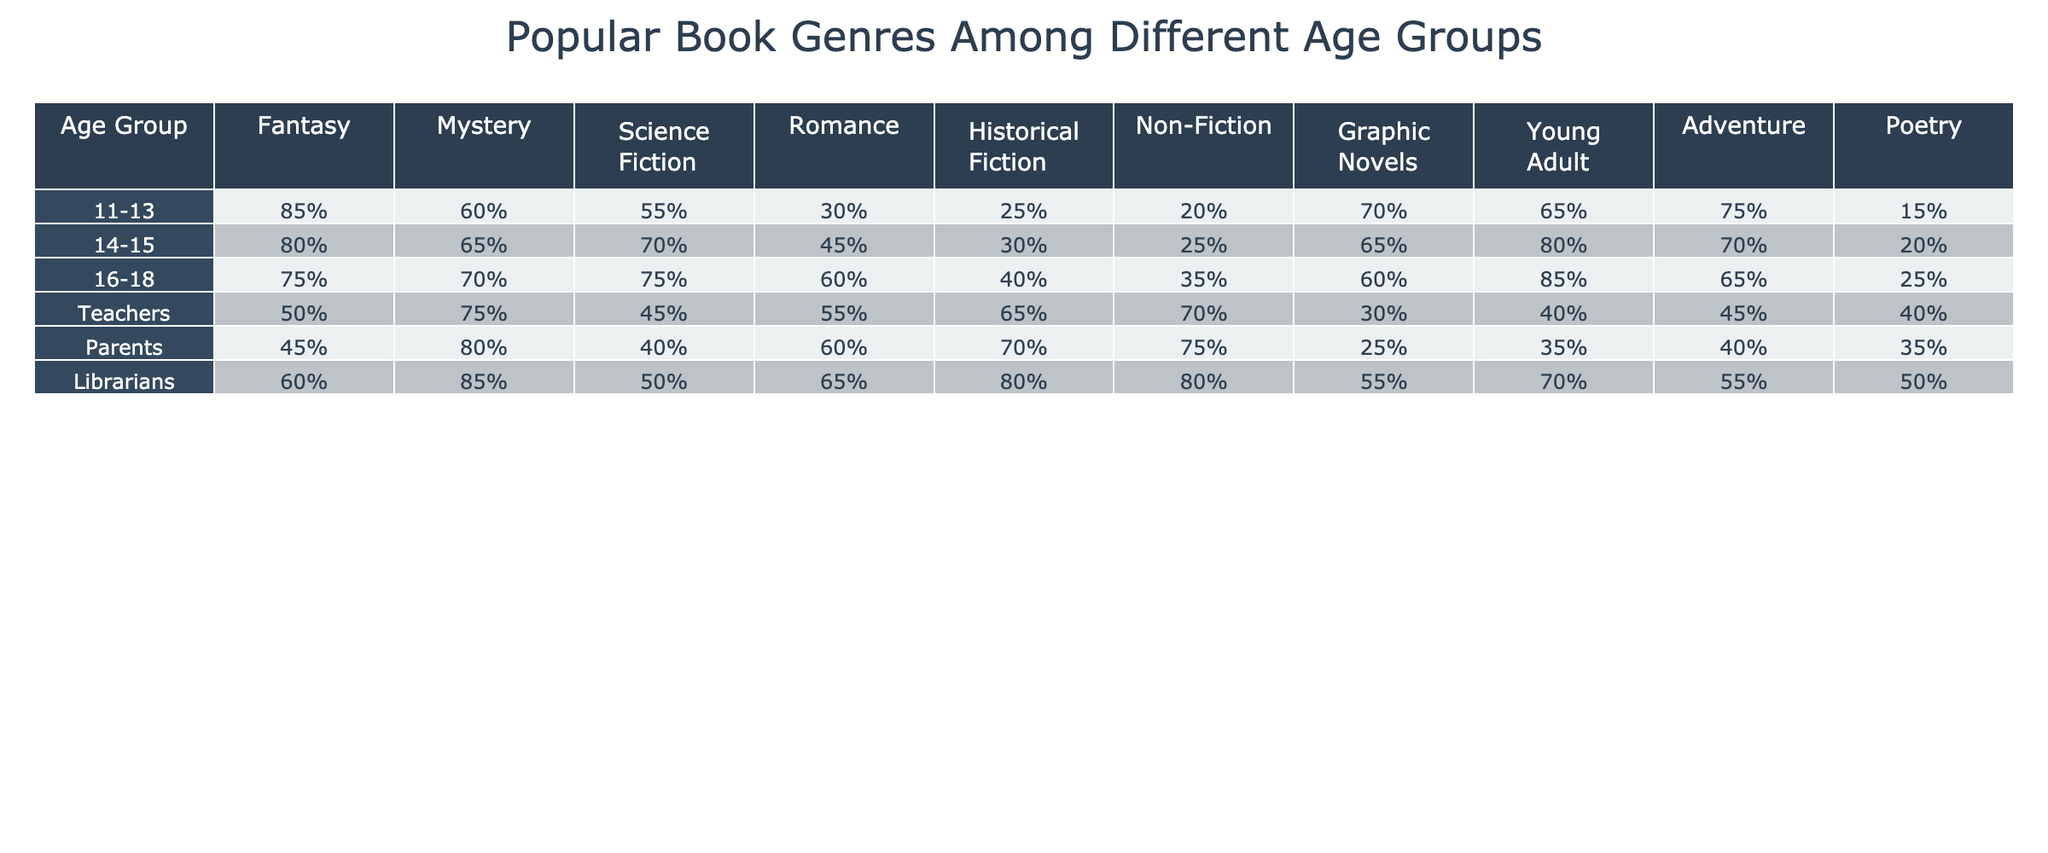What age group has the highest preference for Fantasy books? In the table, the highest percentage for Fantasy books is found in the 11-13 age group at 85%.
Answer: 11-13 Which age group shows the least interest in Poetry? The table shows that the 11-13 age group has the lowest interest in Poetry at 15%.
Answer: 11-13 What is the percentage of parents who prefer Mystery books? From the table, parents have a preference of 80% for Mystery books.
Answer: 80% What is the average percentage of Graphic Novels preferred by the 14-15 and 16-18 age groups? The preferences for the 14-15 age group is 65% and for the 16-18 age group is 60%. The average is calculated as (65 + 60) / 2 = 62.5%.
Answer: 62.5% Are Librarians more interested in Romance books than Teachers? The table shows Librarians have a preference of 65% for Romance, while Teachers have a preference of 55%, thus the statement is true.
Answer: Yes What is the difference in the percentage of Science Fiction preference between the 14-15 and the 16-18 age groups? The 14-15 age group prefers Science Fiction at 70%, and the 16-18 age group at 75%. The difference is 75 - 70 = 5%.
Answer: 5% Which age group has the highest percentage for Young Adult books? The table indicates that the 16-18 age group has the highest preference for Young Adult books at 85%.
Answer: 16-18 How many genres do parents prefer at 60% or more? Parents have preferences of 80% for Mystery, 60% for Romance, and 70% for Historical Fiction, totaling 3 genres that meet this criteria.
Answer: 3 What percentage of Non-Fiction do younger teenagers (11-15) prefer on average? The average percentage for Non-Fiction in the 11-13 age group is 20% and 14-15 age group is 25%, so (20 + 25) / 2 = 22.5%.
Answer: 22.5% Is the percentage preference for Adventure books higher in the 14-15 age group compared to the 11-13 age group? The Adventure preference for 14-15 age group is 70%, while for 11-13 age group it is 75%. This means it is not higher; hence the statement is false.
Answer: No 